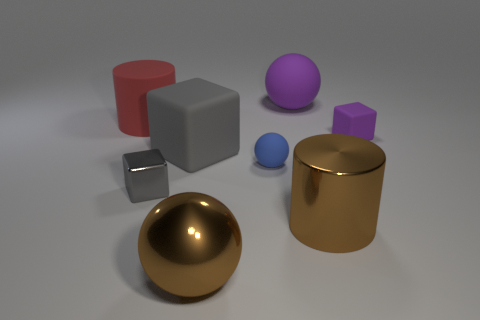Is the metal sphere the same color as the large metal cylinder? Yes, the metal sphere and the large metal cylinder both exhibit a golden hue with reflective properties indicative of polished metallic surfaces. 